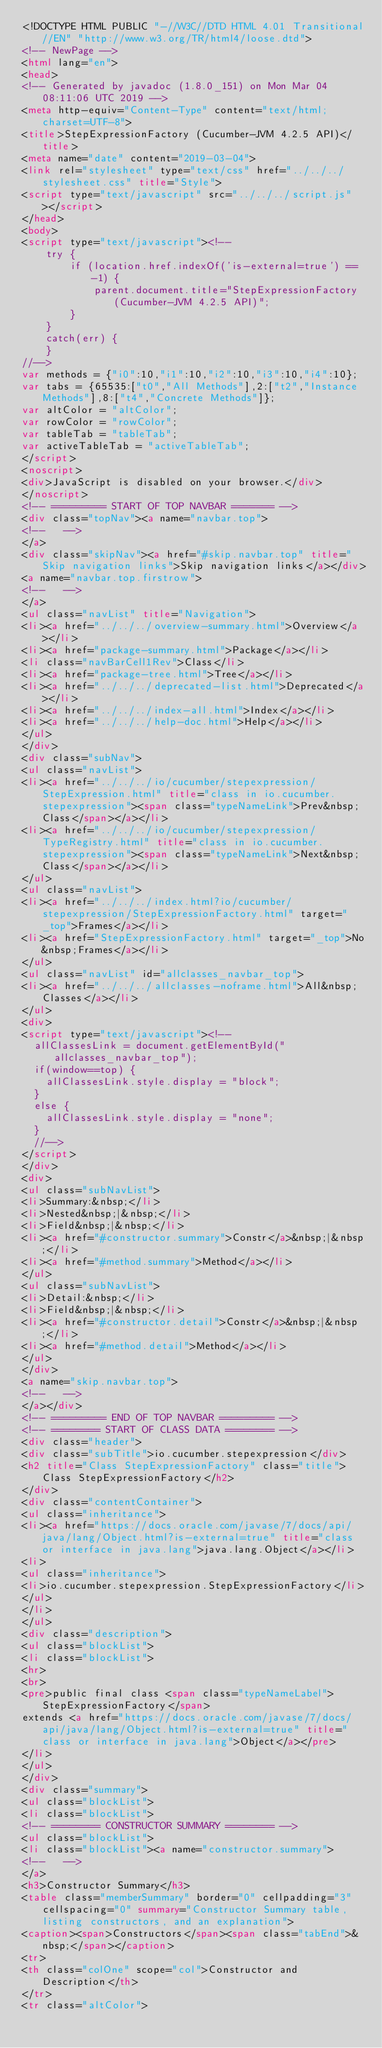<code> <loc_0><loc_0><loc_500><loc_500><_HTML_><!DOCTYPE HTML PUBLIC "-//W3C//DTD HTML 4.01 Transitional//EN" "http://www.w3.org/TR/html4/loose.dtd">
<!-- NewPage -->
<html lang="en">
<head>
<!-- Generated by javadoc (1.8.0_151) on Mon Mar 04 08:11:06 UTC 2019 -->
<meta http-equiv="Content-Type" content="text/html; charset=UTF-8">
<title>StepExpressionFactory (Cucumber-JVM 4.2.5 API)</title>
<meta name="date" content="2019-03-04">
<link rel="stylesheet" type="text/css" href="../../../stylesheet.css" title="Style">
<script type="text/javascript" src="../../../script.js"></script>
</head>
<body>
<script type="text/javascript"><!--
    try {
        if (location.href.indexOf('is-external=true') == -1) {
            parent.document.title="StepExpressionFactory (Cucumber-JVM 4.2.5 API)";
        }
    }
    catch(err) {
    }
//-->
var methods = {"i0":10,"i1":10,"i2":10,"i3":10,"i4":10};
var tabs = {65535:["t0","All Methods"],2:["t2","Instance Methods"],8:["t4","Concrete Methods"]};
var altColor = "altColor";
var rowColor = "rowColor";
var tableTab = "tableTab";
var activeTableTab = "activeTableTab";
</script>
<noscript>
<div>JavaScript is disabled on your browser.</div>
</noscript>
<!-- ========= START OF TOP NAVBAR ======= -->
<div class="topNav"><a name="navbar.top">
<!--   -->
</a>
<div class="skipNav"><a href="#skip.navbar.top" title="Skip navigation links">Skip navigation links</a></div>
<a name="navbar.top.firstrow">
<!--   -->
</a>
<ul class="navList" title="Navigation">
<li><a href="../../../overview-summary.html">Overview</a></li>
<li><a href="package-summary.html">Package</a></li>
<li class="navBarCell1Rev">Class</li>
<li><a href="package-tree.html">Tree</a></li>
<li><a href="../../../deprecated-list.html">Deprecated</a></li>
<li><a href="../../../index-all.html">Index</a></li>
<li><a href="../../../help-doc.html">Help</a></li>
</ul>
</div>
<div class="subNav">
<ul class="navList">
<li><a href="../../../io/cucumber/stepexpression/StepExpression.html" title="class in io.cucumber.stepexpression"><span class="typeNameLink">Prev&nbsp;Class</span></a></li>
<li><a href="../../../io/cucumber/stepexpression/TypeRegistry.html" title="class in io.cucumber.stepexpression"><span class="typeNameLink">Next&nbsp;Class</span></a></li>
</ul>
<ul class="navList">
<li><a href="../../../index.html?io/cucumber/stepexpression/StepExpressionFactory.html" target="_top">Frames</a></li>
<li><a href="StepExpressionFactory.html" target="_top">No&nbsp;Frames</a></li>
</ul>
<ul class="navList" id="allclasses_navbar_top">
<li><a href="../../../allclasses-noframe.html">All&nbsp;Classes</a></li>
</ul>
<div>
<script type="text/javascript"><!--
  allClassesLink = document.getElementById("allclasses_navbar_top");
  if(window==top) {
    allClassesLink.style.display = "block";
  }
  else {
    allClassesLink.style.display = "none";
  }
  //-->
</script>
</div>
<div>
<ul class="subNavList">
<li>Summary:&nbsp;</li>
<li>Nested&nbsp;|&nbsp;</li>
<li>Field&nbsp;|&nbsp;</li>
<li><a href="#constructor.summary">Constr</a>&nbsp;|&nbsp;</li>
<li><a href="#method.summary">Method</a></li>
</ul>
<ul class="subNavList">
<li>Detail:&nbsp;</li>
<li>Field&nbsp;|&nbsp;</li>
<li><a href="#constructor.detail">Constr</a>&nbsp;|&nbsp;</li>
<li><a href="#method.detail">Method</a></li>
</ul>
</div>
<a name="skip.navbar.top">
<!--   -->
</a></div>
<!-- ========= END OF TOP NAVBAR ========= -->
<!-- ======== START OF CLASS DATA ======== -->
<div class="header">
<div class="subTitle">io.cucumber.stepexpression</div>
<h2 title="Class StepExpressionFactory" class="title">Class StepExpressionFactory</h2>
</div>
<div class="contentContainer">
<ul class="inheritance">
<li><a href="https://docs.oracle.com/javase/7/docs/api/java/lang/Object.html?is-external=true" title="class or interface in java.lang">java.lang.Object</a></li>
<li>
<ul class="inheritance">
<li>io.cucumber.stepexpression.StepExpressionFactory</li>
</ul>
</li>
</ul>
<div class="description">
<ul class="blockList">
<li class="blockList">
<hr>
<br>
<pre>public final class <span class="typeNameLabel">StepExpressionFactory</span>
extends <a href="https://docs.oracle.com/javase/7/docs/api/java/lang/Object.html?is-external=true" title="class or interface in java.lang">Object</a></pre>
</li>
</ul>
</div>
<div class="summary">
<ul class="blockList">
<li class="blockList">
<!-- ======== CONSTRUCTOR SUMMARY ======== -->
<ul class="blockList">
<li class="blockList"><a name="constructor.summary">
<!--   -->
</a>
<h3>Constructor Summary</h3>
<table class="memberSummary" border="0" cellpadding="3" cellspacing="0" summary="Constructor Summary table, listing constructors, and an explanation">
<caption><span>Constructors</span><span class="tabEnd">&nbsp;</span></caption>
<tr>
<th class="colOne" scope="col">Constructor and Description</th>
</tr>
<tr class="altColor"></code> 